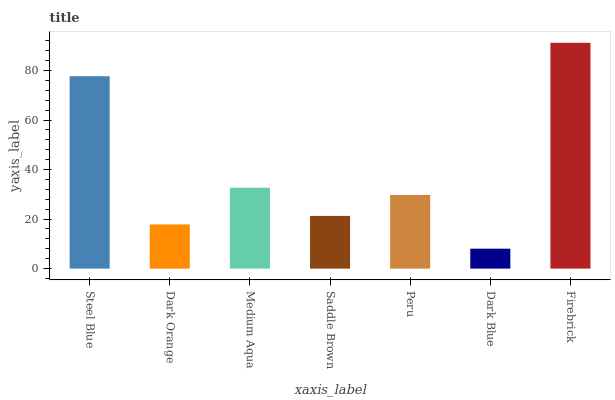Is Dark Blue the minimum?
Answer yes or no. Yes. Is Firebrick the maximum?
Answer yes or no. Yes. Is Dark Orange the minimum?
Answer yes or no. No. Is Dark Orange the maximum?
Answer yes or no. No. Is Steel Blue greater than Dark Orange?
Answer yes or no. Yes. Is Dark Orange less than Steel Blue?
Answer yes or no. Yes. Is Dark Orange greater than Steel Blue?
Answer yes or no. No. Is Steel Blue less than Dark Orange?
Answer yes or no. No. Is Peru the high median?
Answer yes or no. Yes. Is Peru the low median?
Answer yes or no. Yes. Is Steel Blue the high median?
Answer yes or no. No. Is Dark Blue the low median?
Answer yes or no. No. 